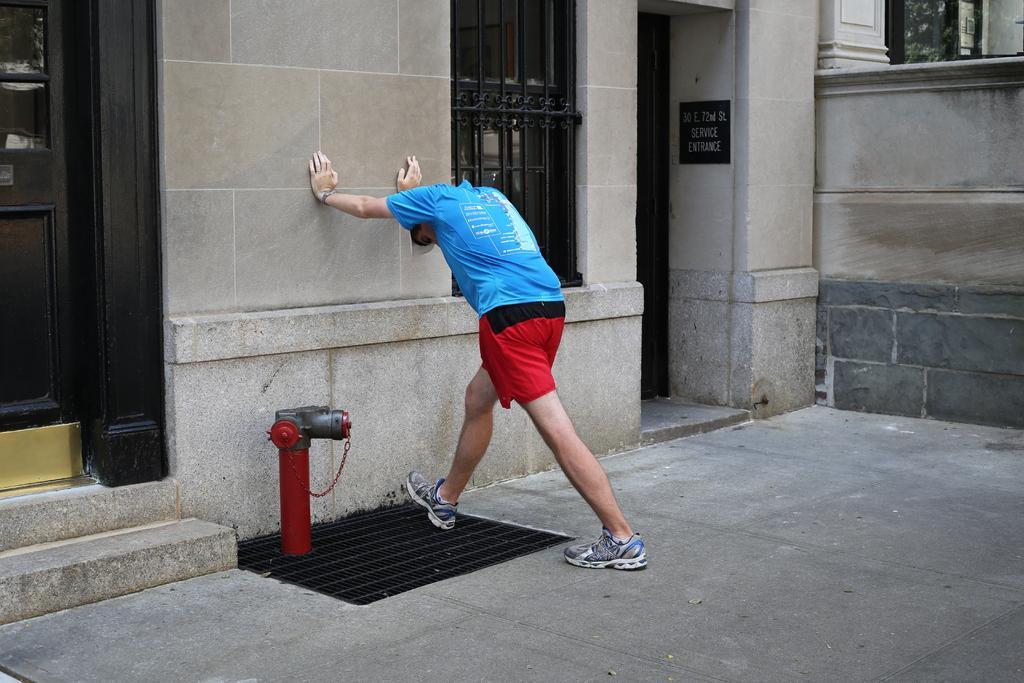Can you describe this image briefly? In this picture I can see there is a man standing he is wearing a blue shirt and a red trouser and in the backdrop I can see there is a building, it has door, windows and there is a wall. 